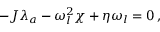Convert formula to latex. <formula><loc_0><loc_0><loc_500><loc_500>- J \lambda _ { a } - \omega _ { l } ^ { 2 } \chi + \eta \omega _ { l } = 0 \, ,</formula> 